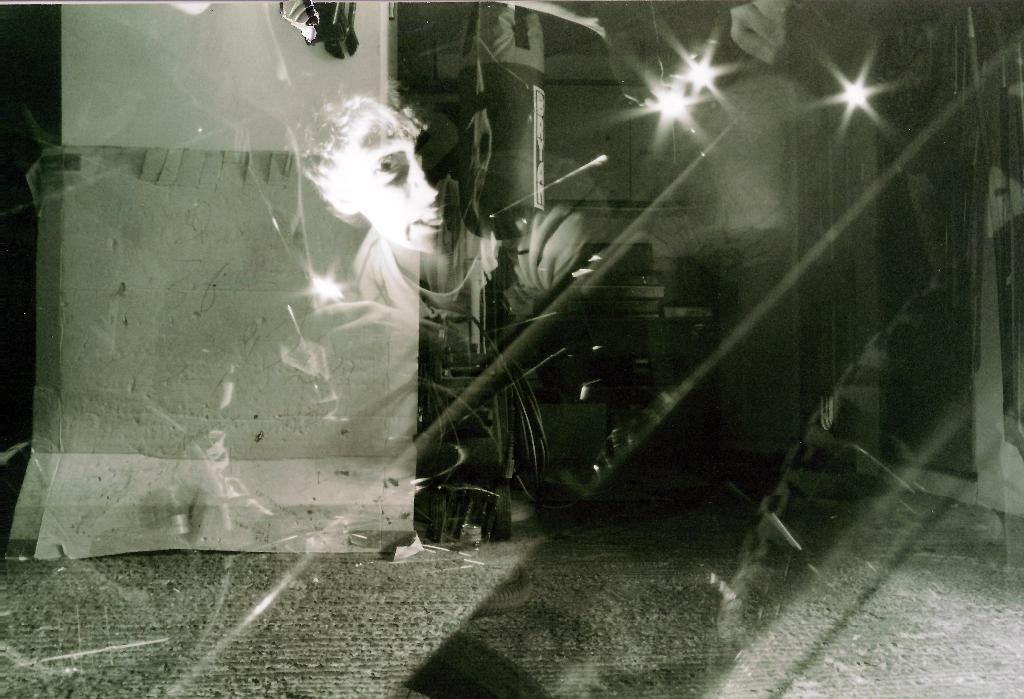Please provide a concise description of this image. There is a boy's reflection on a glass as we can see in the middle of this image. We can see a cardboard, a wall and other objects in the background. 